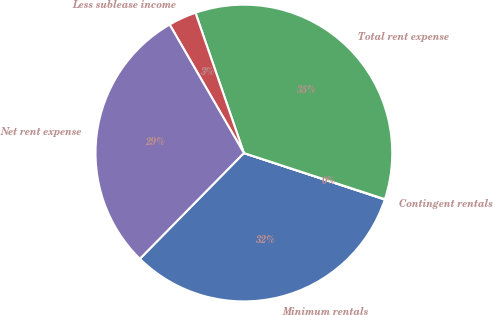Convert chart to OTSL. <chart><loc_0><loc_0><loc_500><loc_500><pie_chart><fcel>Minimum rentals<fcel>Contingent rentals<fcel>Total rent expense<fcel>Less sublease income<fcel>Net rent expense<nl><fcel>32.3%<fcel>0.04%<fcel>35.32%<fcel>3.05%<fcel>29.29%<nl></chart> 